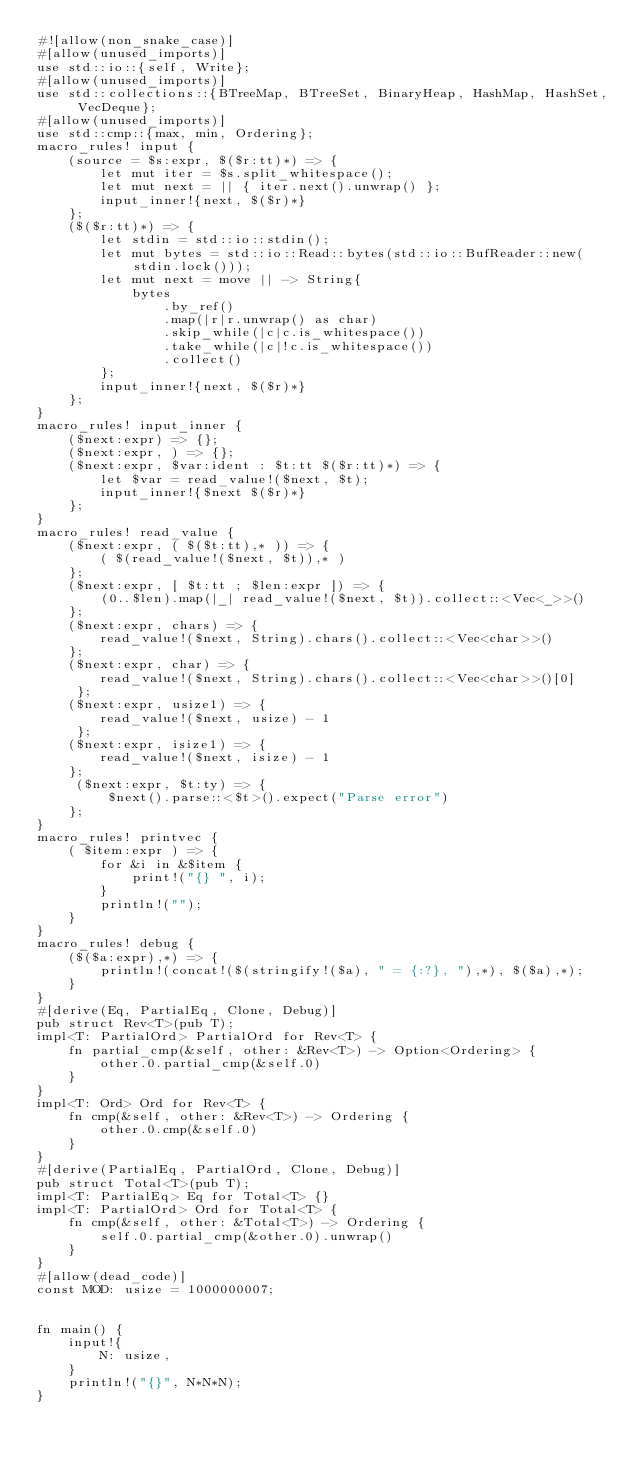<code> <loc_0><loc_0><loc_500><loc_500><_Rust_>#![allow(non_snake_case)]
#[allow(unused_imports)]
use std::io::{self, Write};
#[allow(unused_imports)]
use std::collections::{BTreeMap, BTreeSet, BinaryHeap, HashMap, HashSet, VecDeque};
#[allow(unused_imports)]
use std::cmp::{max, min, Ordering};
macro_rules! input {
    (source = $s:expr, $($r:tt)*) => {
        let mut iter = $s.split_whitespace();
        let mut next = || { iter.next().unwrap() };
        input_inner!{next, $($r)*}
    };
    ($($r:tt)*) => {
        let stdin = std::io::stdin();
        let mut bytes = std::io::Read::bytes(std::io::BufReader::new(stdin.lock()));
        let mut next = move || -> String{
            bytes
                .by_ref()
                .map(|r|r.unwrap() as char)
                .skip_while(|c|c.is_whitespace())
                .take_while(|c|!c.is_whitespace())
                .collect()
        };
        input_inner!{next, $($r)*}
    };
}
macro_rules! input_inner {
    ($next:expr) => {};
    ($next:expr, ) => {};
    ($next:expr, $var:ident : $t:tt $($r:tt)*) => {
        let $var = read_value!($next, $t);
        input_inner!{$next $($r)*}
    };
}
macro_rules! read_value {
    ($next:expr, ( $($t:tt),* )) => {
        ( $(read_value!($next, $t)),* )
    };
    ($next:expr, [ $t:tt ; $len:expr ]) => {
        (0..$len).map(|_| read_value!($next, $t)).collect::<Vec<_>>()
    };
    ($next:expr, chars) => {
        read_value!($next, String).chars().collect::<Vec<char>>()
    };
    ($next:expr, char) => {
        read_value!($next, String).chars().collect::<Vec<char>>()[0]
     };
    ($next:expr, usize1) => {
        read_value!($next, usize) - 1
     };
    ($next:expr, isize1) => {
        read_value!($next, isize) - 1
    };
     ($next:expr, $t:ty) => {
         $next().parse::<$t>().expect("Parse error")
    };
}
macro_rules! printvec {
    ( $item:expr ) => {
        for &i in &$item {
            print!("{} ", i);
        }
        println!("");
    }
}
macro_rules! debug {
    ($($a:expr),*) => {
        println!(concat!($(stringify!($a), " = {:?}, "),*), $($a),*);
    }
}
#[derive(Eq, PartialEq, Clone, Debug)]
pub struct Rev<T>(pub T);
impl<T: PartialOrd> PartialOrd for Rev<T> {
    fn partial_cmp(&self, other: &Rev<T>) -> Option<Ordering> {
        other.0.partial_cmp(&self.0)
    }
}
impl<T: Ord> Ord for Rev<T> {
    fn cmp(&self, other: &Rev<T>) -> Ordering {
        other.0.cmp(&self.0)
    }
}
#[derive(PartialEq, PartialOrd, Clone, Debug)]
pub struct Total<T>(pub T);
impl<T: PartialEq> Eq for Total<T> {}
impl<T: PartialOrd> Ord for Total<T> {
    fn cmp(&self, other: &Total<T>) -> Ordering {
        self.0.partial_cmp(&other.0).unwrap()
    }
}
#[allow(dead_code)]
const MOD: usize = 1000000007;


fn main() {
    input!{
        N: usize,
    }
    println!("{}", N*N*N);
}</code> 